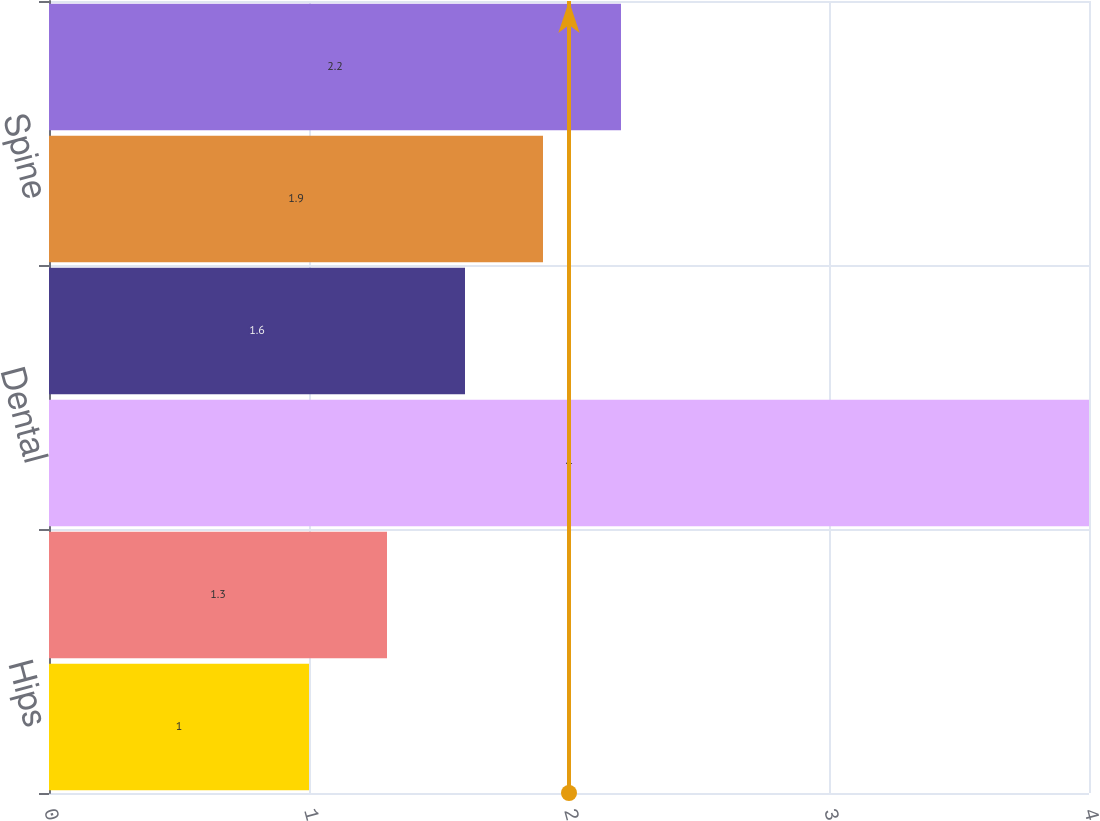Convert chart to OTSL. <chart><loc_0><loc_0><loc_500><loc_500><bar_chart><fcel>Hips<fcel>Extremities<fcel>Dental<fcel>Trauma<fcel>Spine<fcel>OSP and other<nl><fcel>1<fcel>1.3<fcel>4<fcel>1.6<fcel>1.9<fcel>2.2<nl></chart> 